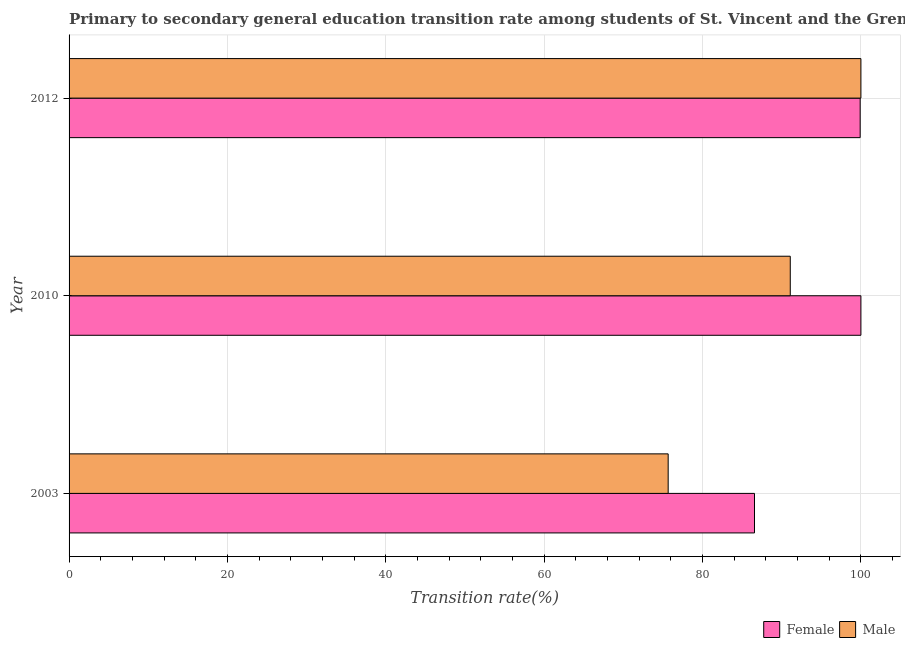What is the transition rate among male students in 2010?
Offer a terse response. 91.08. Across all years, what is the minimum transition rate among male students?
Make the answer very short. 75.66. In which year was the transition rate among male students minimum?
Make the answer very short. 2003. What is the total transition rate among female students in the graph?
Provide a succinct answer. 286.47. What is the difference between the transition rate among female students in 2003 and that in 2012?
Your answer should be compact. -13.34. What is the difference between the transition rate among male students in 2010 and the transition rate among female students in 2003?
Ensure brevity in your answer.  4.52. What is the average transition rate among male students per year?
Your answer should be compact. 88.91. In the year 2003, what is the difference between the transition rate among male students and transition rate among female students?
Keep it short and to the point. -10.9. What is the ratio of the transition rate among male students in 2003 to that in 2010?
Your response must be concise. 0.83. What is the difference between the highest and the second highest transition rate among male students?
Your answer should be very brief. 8.92. What is the difference between the highest and the lowest transition rate among male students?
Keep it short and to the point. 24.34. How many bars are there?
Keep it short and to the point. 6. Are all the bars in the graph horizontal?
Your answer should be compact. Yes. How many years are there in the graph?
Your answer should be compact. 3. Are the values on the major ticks of X-axis written in scientific E-notation?
Keep it short and to the point. No. Does the graph contain any zero values?
Offer a terse response. No. Where does the legend appear in the graph?
Provide a short and direct response. Bottom right. How are the legend labels stacked?
Make the answer very short. Horizontal. What is the title of the graph?
Your response must be concise. Primary to secondary general education transition rate among students of St. Vincent and the Grenadines. Does "Mobile cellular" appear as one of the legend labels in the graph?
Your answer should be very brief. No. What is the label or title of the X-axis?
Your answer should be compact. Transition rate(%). What is the Transition rate(%) in Female in 2003?
Offer a very short reply. 86.56. What is the Transition rate(%) of Male in 2003?
Give a very brief answer. 75.66. What is the Transition rate(%) in Male in 2010?
Provide a succinct answer. 91.08. What is the Transition rate(%) of Female in 2012?
Provide a succinct answer. 99.91. What is the Transition rate(%) in Male in 2012?
Your response must be concise. 100. Across all years, what is the minimum Transition rate(%) of Female?
Provide a short and direct response. 86.56. Across all years, what is the minimum Transition rate(%) in Male?
Ensure brevity in your answer.  75.66. What is the total Transition rate(%) in Female in the graph?
Provide a short and direct response. 286.47. What is the total Transition rate(%) of Male in the graph?
Offer a terse response. 266.74. What is the difference between the Transition rate(%) in Female in 2003 and that in 2010?
Offer a very short reply. -13.44. What is the difference between the Transition rate(%) in Male in 2003 and that in 2010?
Keep it short and to the point. -15.42. What is the difference between the Transition rate(%) of Female in 2003 and that in 2012?
Your response must be concise. -13.34. What is the difference between the Transition rate(%) of Male in 2003 and that in 2012?
Give a very brief answer. -24.34. What is the difference between the Transition rate(%) in Female in 2010 and that in 2012?
Give a very brief answer. 0.09. What is the difference between the Transition rate(%) in Male in 2010 and that in 2012?
Keep it short and to the point. -8.92. What is the difference between the Transition rate(%) of Female in 2003 and the Transition rate(%) of Male in 2010?
Offer a very short reply. -4.52. What is the difference between the Transition rate(%) in Female in 2003 and the Transition rate(%) in Male in 2012?
Make the answer very short. -13.44. What is the difference between the Transition rate(%) of Female in 2010 and the Transition rate(%) of Male in 2012?
Offer a very short reply. 0. What is the average Transition rate(%) in Female per year?
Make the answer very short. 95.49. What is the average Transition rate(%) of Male per year?
Your answer should be very brief. 88.91. In the year 2003, what is the difference between the Transition rate(%) of Female and Transition rate(%) of Male?
Make the answer very short. 10.9. In the year 2010, what is the difference between the Transition rate(%) in Female and Transition rate(%) in Male?
Provide a succinct answer. 8.92. In the year 2012, what is the difference between the Transition rate(%) in Female and Transition rate(%) in Male?
Your answer should be very brief. -0.09. What is the ratio of the Transition rate(%) in Female in 2003 to that in 2010?
Your response must be concise. 0.87. What is the ratio of the Transition rate(%) in Male in 2003 to that in 2010?
Make the answer very short. 0.83. What is the ratio of the Transition rate(%) of Female in 2003 to that in 2012?
Provide a succinct answer. 0.87. What is the ratio of the Transition rate(%) of Male in 2003 to that in 2012?
Your answer should be very brief. 0.76. What is the ratio of the Transition rate(%) in Male in 2010 to that in 2012?
Make the answer very short. 0.91. What is the difference between the highest and the second highest Transition rate(%) in Female?
Your response must be concise. 0.09. What is the difference between the highest and the second highest Transition rate(%) in Male?
Your response must be concise. 8.92. What is the difference between the highest and the lowest Transition rate(%) in Female?
Give a very brief answer. 13.44. What is the difference between the highest and the lowest Transition rate(%) in Male?
Give a very brief answer. 24.34. 